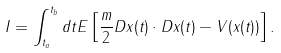<formula> <loc_0><loc_0><loc_500><loc_500>I = \int _ { t _ { a } } ^ { t _ { b } } d t E \left [ \frac { m } { 2 } D x ( t ) \cdot D x ( t ) - V ( x ( t ) ) \right ] .</formula> 